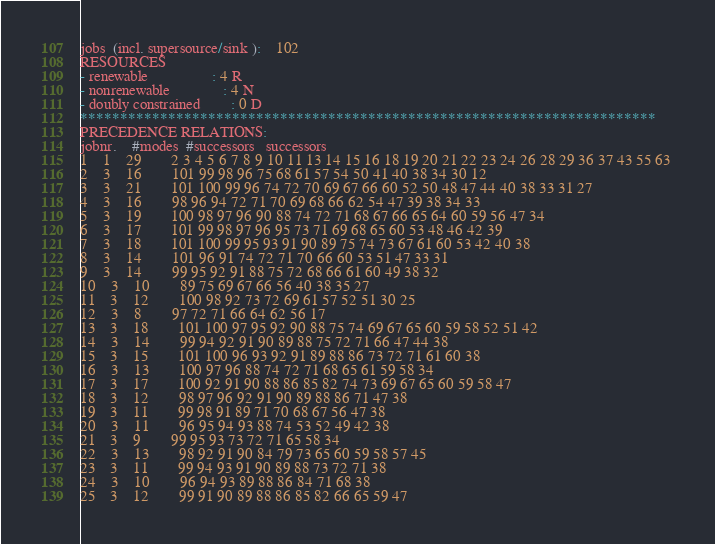Convert code to text. <code><loc_0><loc_0><loc_500><loc_500><_ObjectiveC_>jobs  (incl. supersource/sink ):	102
RESOURCES
- renewable                 : 4 R
- nonrenewable              : 4 N
- doubly constrained        : 0 D
************************************************************************
PRECEDENCE RELATIONS:
jobnr.    #modes  #successors   successors
1	1	29		2 3 4 5 6 7 8 9 10 11 13 14 15 16 18 19 20 21 22 23 24 26 28 29 36 37 43 55 63 
2	3	16		101 99 98 96 75 68 61 57 54 50 41 40 38 34 30 12 
3	3	21		101 100 99 96 74 72 70 69 67 66 60 52 50 48 47 44 40 38 33 31 27 
4	3	16		98 96 94 72 71 70 69 68 66 62 54 47 39 38 34 33 
5	3	19		100 98 97 96 90 88 74 72 71 68 67 66 65 64 60 59 56 47 34 
6	3	17		101 99 98 97 96 95 73 71 69 68 65 60 53 48 46 42 39 
7	3	18		101 100 99 95 93 91 90 89 75 74 73 67 61 60 53 42 40 38 
8	3	14		101 96 91 74 72 71 70 66 60 53 51 47 33 31 
9	3	14		99 95 92 91 88 75 72 68 66 61 60 49 38 32 
10	3	10		89 75 69 67 66 56 40 38 35 27 
11	3	12		100 98 92 73 72 69 61 57 52 51 30 25 
12	3	8		97 72 71 66 64 62 56 17 
13	3	18		101 100 97 95 92 90 88 75 74 69 67 65 60 59 58 52 51 42 
14	3	14		99 94 92 91 90 89 88 75 72 71 66 47 44 38 
15	3	15		101 100 96 93 92 91 89 88 86 73 72 71 61 60 38 
16	3	13		100 97 96 88 74 72 71 68 65 61 59 58 34 
17	3	17		100 92 91 90 88 86 85 82 74 73 69 67 65 60 59 58 47 
18	3	12		98 97 96 92 91 90 89 88 86 71 47 38 
19	3	11		99 98 91 89 71 70 68 67 56 47 38 
20	3	11		96 95 94 93 88 74 53 52 49 42 38 
21	3	9		99 95 93 73 72 71 65 58 34 
22	3	13		98 92 91 90 84 79 73 65 60 59 58 57 45 
23	3	11		99 94 93 91 90 89 88 73 72 71 38 
24	3	10		96 94 93 89 88 86 84 71 68 38 
25	3	12		99 91 90 89 88 86 85 82 66 65 59 47 </code> 